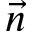Convert formula to latex. <formula><loc_0><loc_0><loc_500><loc_500>\vec { n }</formula> 